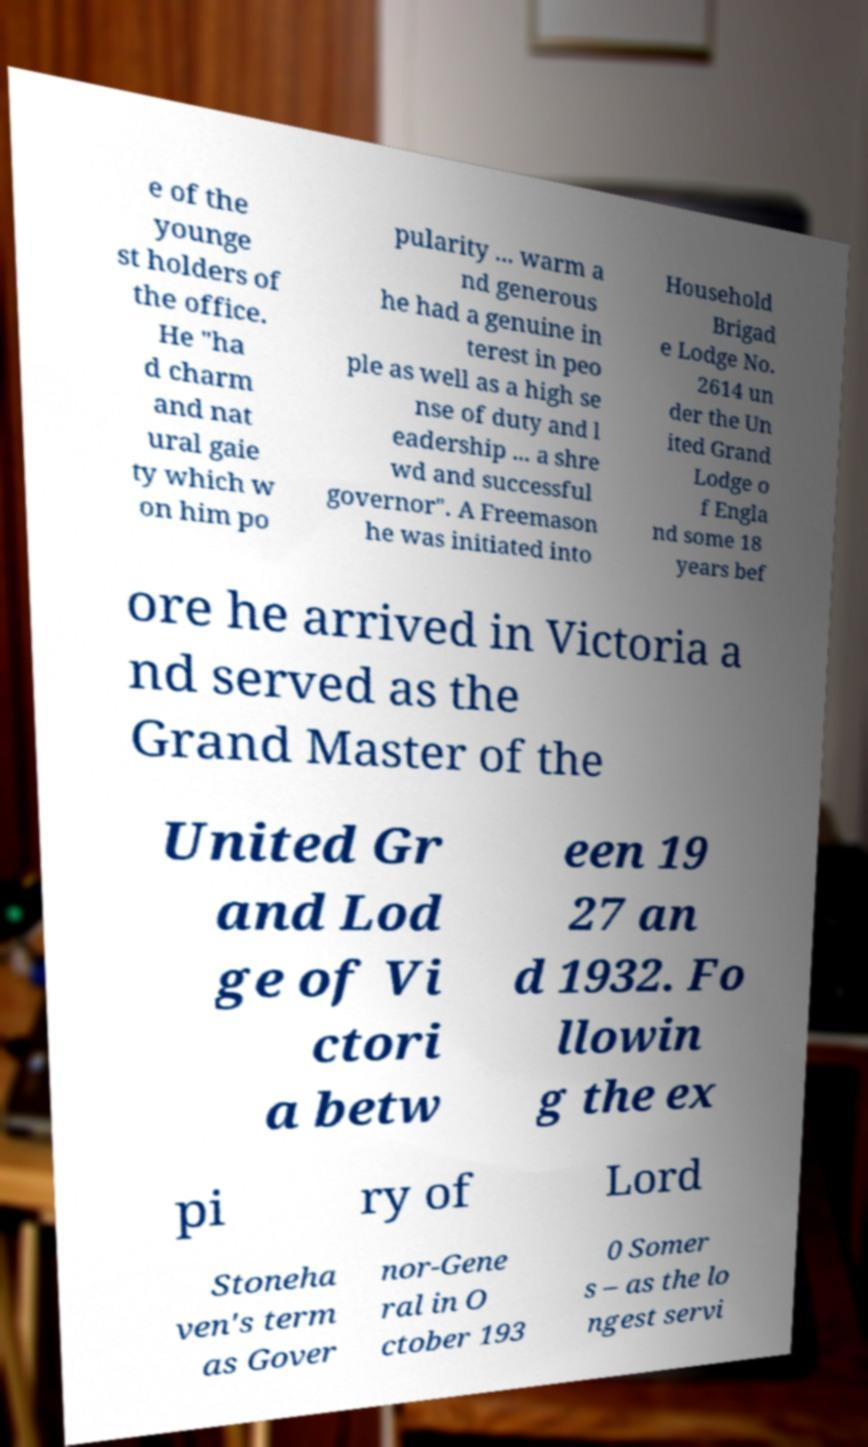Please read and relay the text visible in this image. What does it say? e of the younge st holders of the office. He "ha d charm and nat ural gaie ty which w on him po pularity ... warm a nd generous he had a genuine in terest in peo ple as well as a high se nse of duty and l eadership ... a shre wd and successful governor". A Freemason he was initiated into Household Brigad e Lodge No. 2614 un der the Un ited Grand Lodge o f Engla nd some 18 years bef ore he arrived in Victoria a nd served as the Grand Master of the United Gr and Lod ge of Vi ctori a betw een 19 27 an d 1932. Fo llowin g the ex pi ry of Lord Stoneha ven's term as Gover nor-Gene ral in O ctober 193 0 Somer s – as the lo ngest servi 